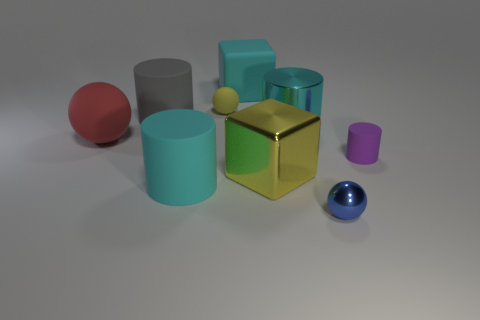How many other things are the same size as the gray cylinder?
Your answer should be compact. 5. There is a cyan object in front of the large cyan metallic cylinder right of the large matte cylinder that is in front of the red rubber sphere; what is it made of?
Offer a very short reply. Rubber. What size is the rubber thing that is the same color as the big matte cube?
Provide a short and direct response. Large. What number of objects are either big green matte spheres or red things?
Make the answer very short. 1. The metal cylinder that is the same size as the red matte sphere is what color?
Offer a terse response. Cyan. There is a big yellow object; is its shape the same as the metallic thing in front of the large cyan matte cylinder?
Provide a short and direct response. No. What number of things are either large cyan matte objects behind the large rubber ball or blocks that are in front of the large gray thing?
Ensure brevity in your answer.  2. What shape is the object that is the same color as the small matte sphere?
Provide a succinct answer. Cube. There is a rubber thing in front of the large shiny block; what shape is it?
Your answer should be very brief. Cylinder. Is the shape of the big object left of the gray rubber cylinder the same as  the tiny yellow object?
Give a very brief answer. Yes. 